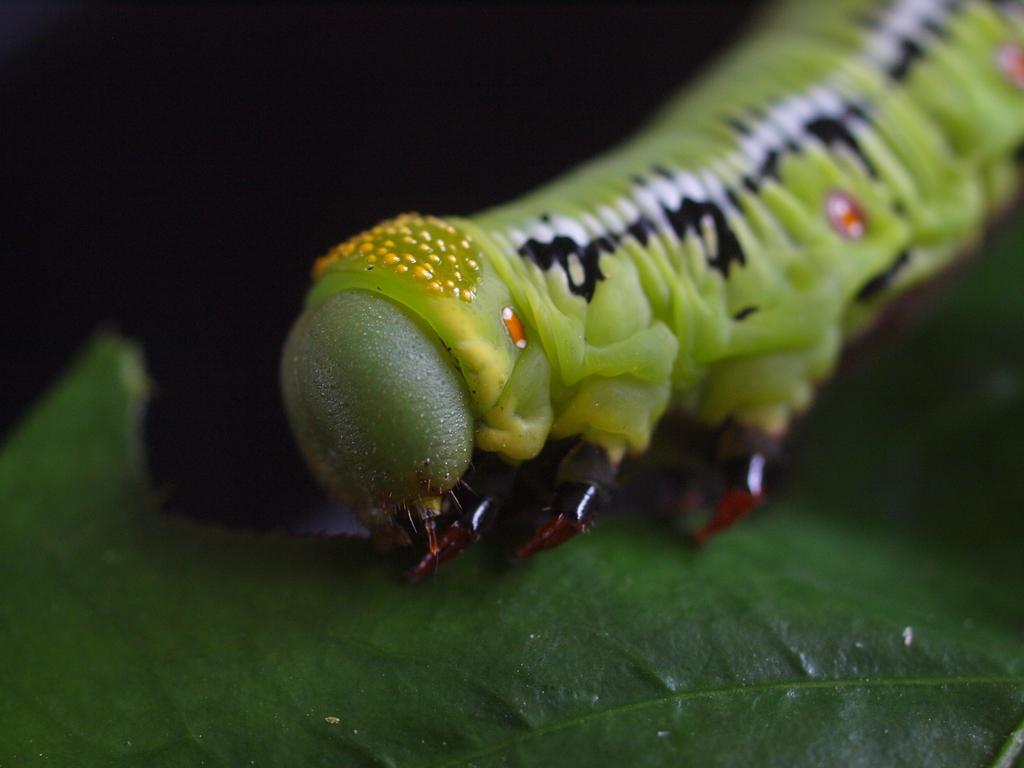Can you describe this image briefly? In this image I can see an insect which is green, black, white, yellow and orange in color. I can see a leaf which is green in color and the black colored background. 